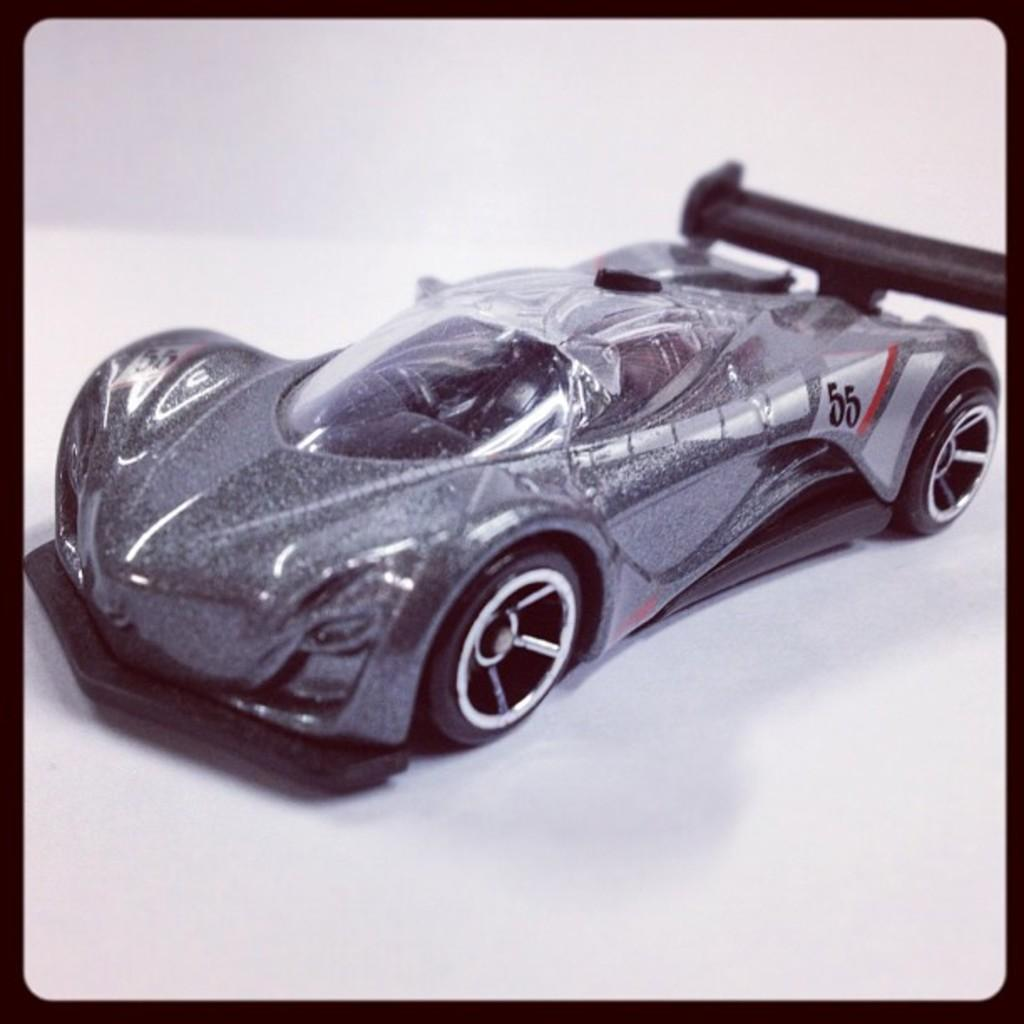<image>
Create a compact narrative representing the image presented. a toy sports car in silver with the number 55 on it 